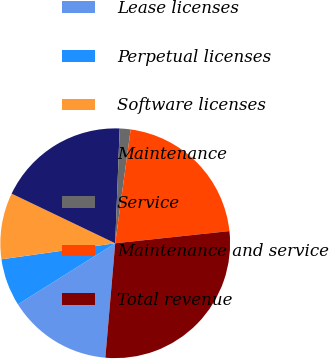<chart> <loc_0><loc_0><loc_500><loc_500><pie_chart><fcel>Lease licenses<fcel>Perpetual licenses<fcel>Software licenses<fcel>Maintenance<fcel>Service<fcel>Maintenance and service<fcel>Total revenue<nl><fcel>14.71%<fcel>6.69%<fcel>9.34%<fcel>18.51%<fcel>1.53%<fcel>21.16%<fcel>28.06%<nl></chart> 